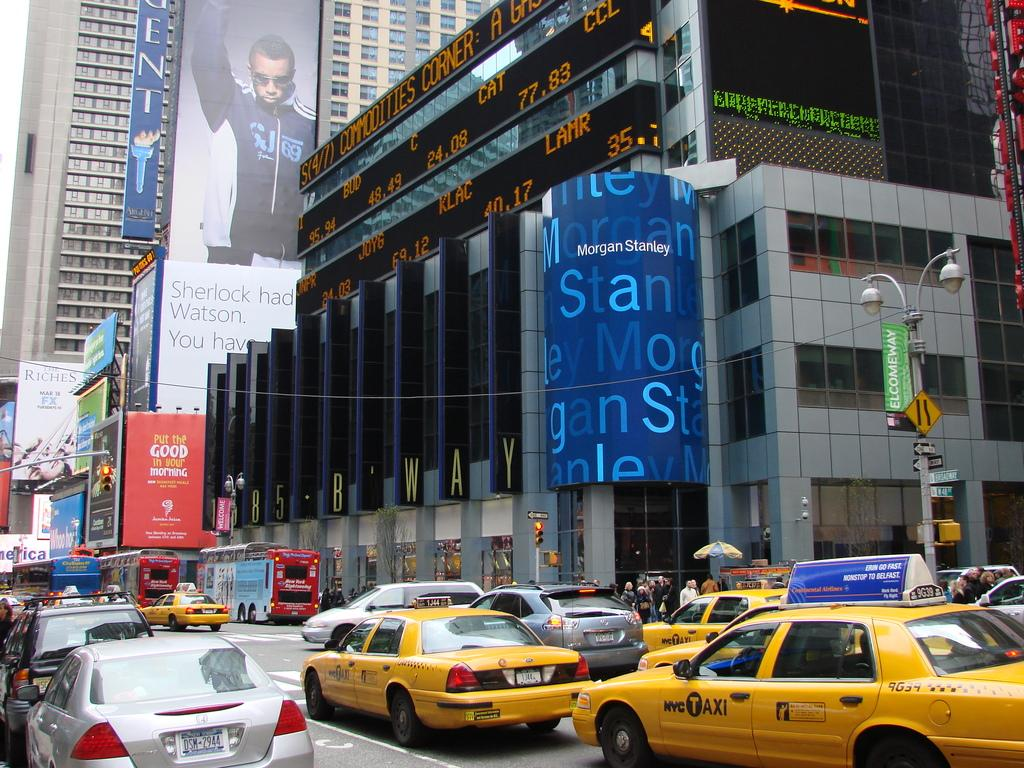Provide a one-sentence caption for the provided image. Many NYC Taxis drive down the street under a large Morgan Stanley blue sign. 